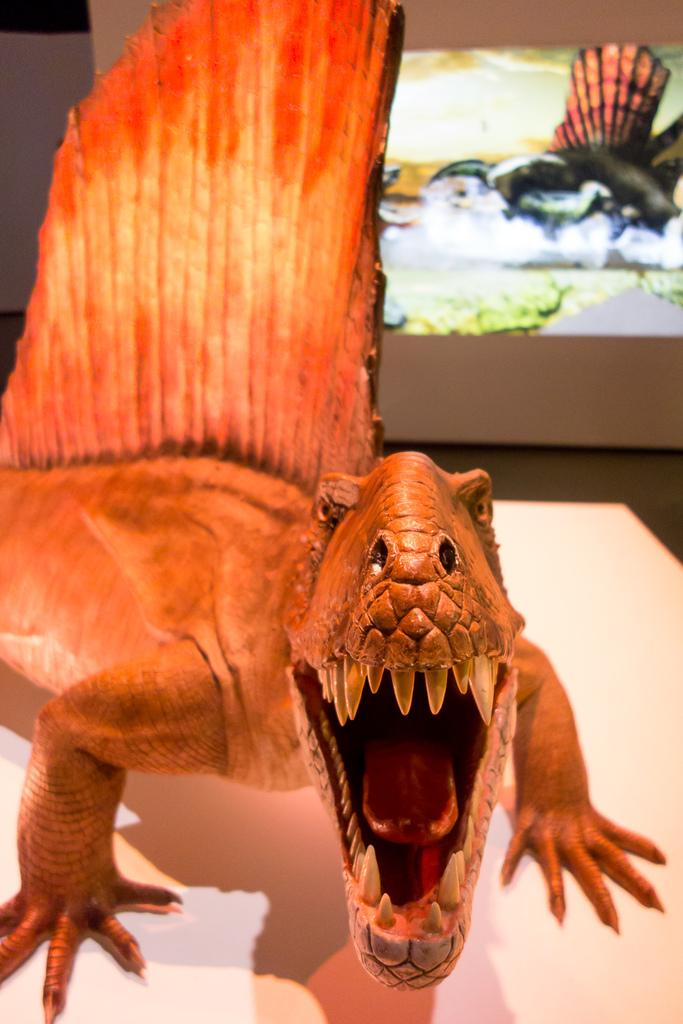What is the main subject of the image? There is a sculpture of an animal in the image. What is the color of the surface on which the sculpture is placed? The sculpture is on a white surface. Can you describe the background of the image? The background of the image is slightly blurred. What type of drain is visible in the image? There is no drain present in the image; it features a sculpture of an animal on a white surface with a slightly blurred background. 